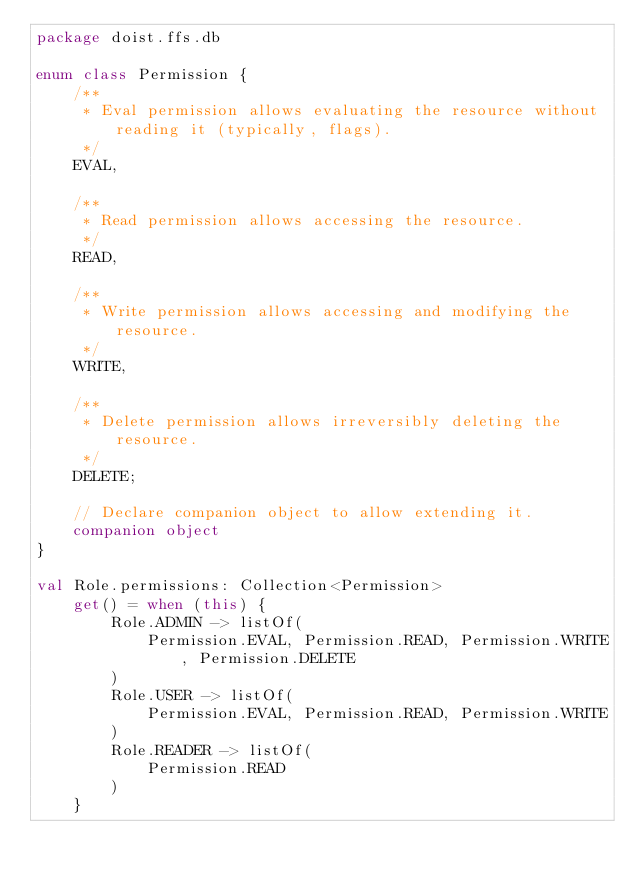<code> <loc_0><loc_0><loc_500><loc_500><_Kotlin_>package doist.ffs.db

enum class Permission {
    /**
     * Eval permission allows evaluating the resource without reading it (typically, flags).
     */
    EVAL,

    /**
     * Read permission allows accessing the resource.
     */
    READ,

    /**
     * Write permission allows accessing and modifying the resource.
     */
    WRITE,

    /**
     * Delete permission allows irreversibly deleting the resource.
     */
    DELETE;

    // Declare companion object to allow extending it.
    companion object
}

val Role.permissions: Collection<Permission>
    get() = when (this) {
        Role.ADMIN -> listOf(
            Permission.EVAL, Permission.READ, Permission.WRITE, Permission.DELETE
        )
        Role.USER -> listOf(
            Permission.EVAL, Permission.READ, Permission.WRITE
        )
        Role.READER -> listOf(
            Permission.READ
        )
    }
</code> 